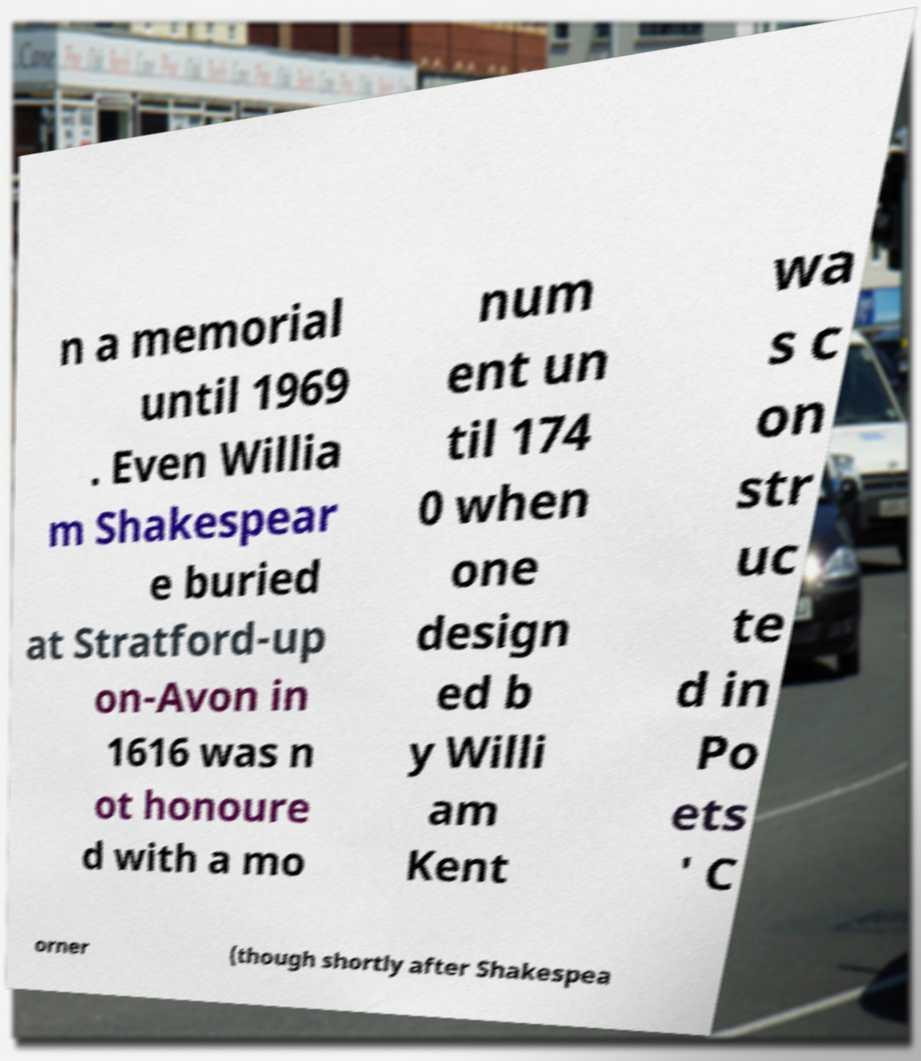Can you read and provide the text displayed in the image?This photo seems to have some interesting text. Can you extract and type it out for me? n a memorial until 1969 . Even Willia m Shakespear e buried at Stratford-up on-Avon in 1616 was n ot honoure d with a mo num ent un til 174 0 when one design ed b y Willi am Kent wa s c on str uc te d in Po ets ' C orner (though shortly after Shakespea 